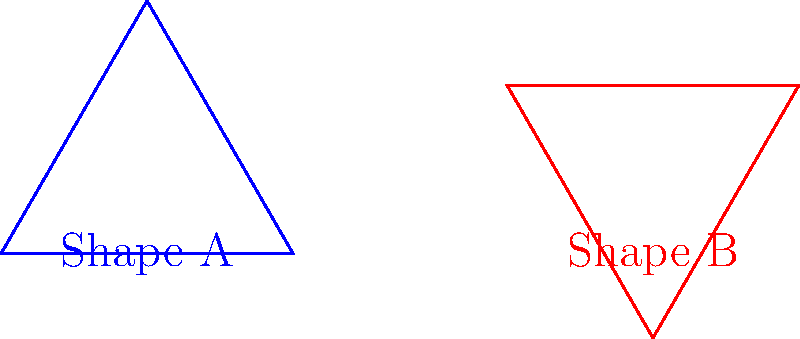Look at the two triangles above. How many degrees clockwise should Shape A be rotated to match the orientation of Shape B? To solve this problem, let's follow these steps:

1. Observe the orientation of both shapes:
   - Shape A has its base horizontal and pointing to the right.
   - Shape B has its base tilted upwards to the right.

2. Understand clockwise rotation:
   - Clockwise rotation means moving in the direction a clock's hands move.

3. Estimate the angle of rotation:
   - We can see that Shape B appears to have rotated about 60° clockwise from the position of Shape A.

4. Confirm the rotation:
   - In an equilateral triangle, each angle is 60°.
   - Rotating Shape A by one full angle of the triangle would align it with Shape B.

5. Verify the answer:
   - If we mentally rotate Shape A by 60° clockwise, it would indeed match the orientation of Shape B.

This type of spatial reasoning is important for children's development, as it helps them understand relationships between objects and their positions in space.
Answer: 60° 